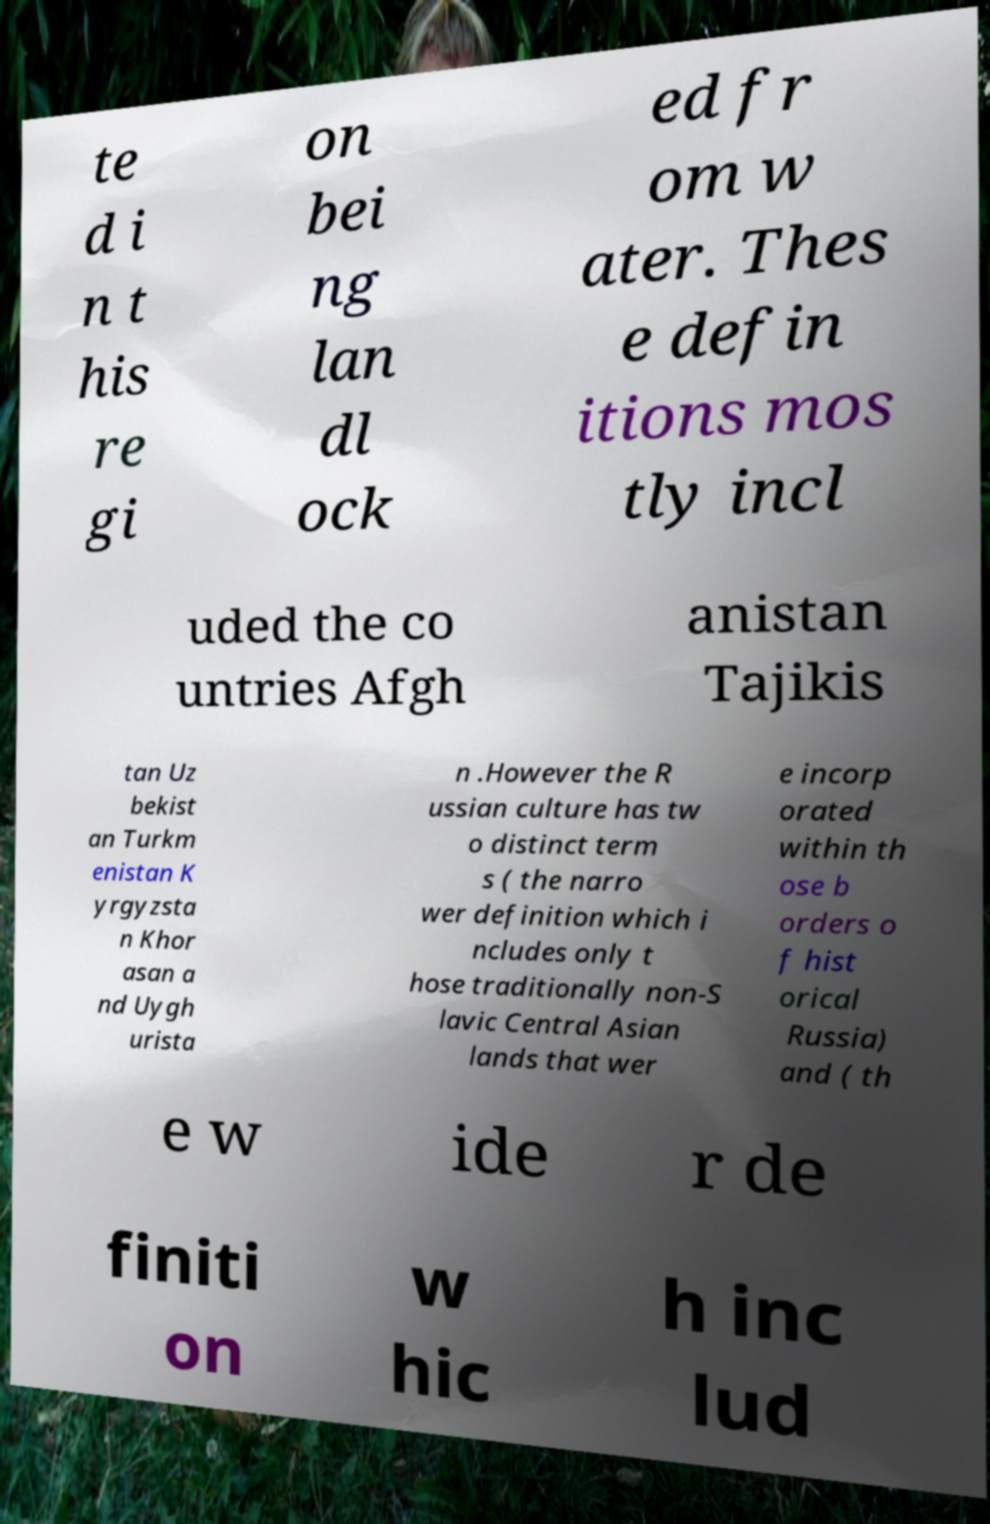Could you extract and type out the text from this image? te d i n t his re gi on bei ng lan dl ock ed fr om w ater. Thes e defin itions mos tly incl uded the co untries Afgh anistan Tajikis tan Uz bekist an Turkm enistan K yrgyzsta n Khor asan a nd Uygh urista n .However the R ussian culture has tw o distinct term s ( the narro wer definition which i ncludes only t hose traditionally non-S lavic Central Asian lands that wer e incorp orated within th ose b orders o f hist orical Russia) and ( th e w ide r de finiti on w hic h inc lud 